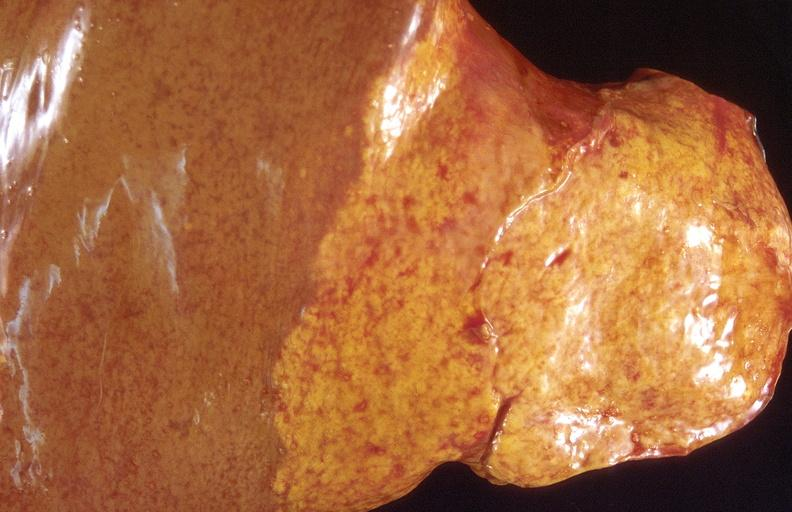what is present?
Answer the question using a single word or phrase. Liver 